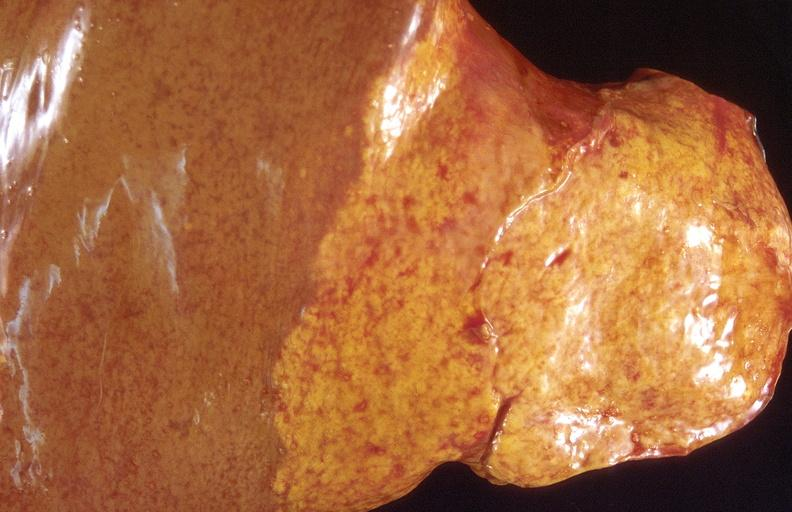what is present?
Answer the question using a single word or phrase. Liver 